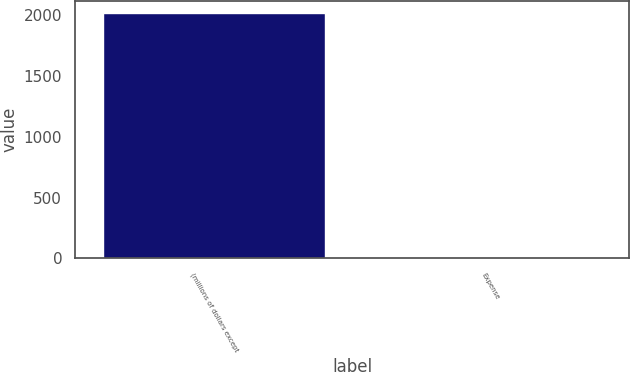Convert chart. <chart><loc_0><loc_0><loc_500><loc_500><bar_chart><fcel>(millions of dollars except<fcel>Expense<nl><fcel>2014<fcel>11.4<nl></chart> 